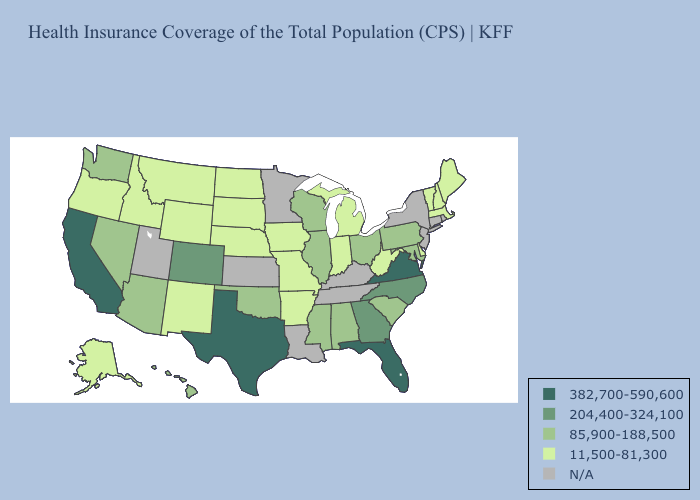What is the lowest value in the USA?
Keep it brief. 11,500-81,300. Name the states that have a value in the range 11,500-81,300?
Short answer required. Alaska, Arkansas, Delaware, Idaho, Indiana, Iowa, Maine, Massachusetts, Michigan, Missouri, Montana, Nebraska, New Hampshire, New Mexico, North Dakota, Oregon, South Dakota, Vermont, West Virginia, Wyoming. Name the states that have a value in the range 204,400-324,100?
Answer briefly. Colorado, Georgia, North Carolina. Name the states that have a value in the range 204,400-324,100?
Quick response, please. Colorado, Georgia, North Carolina. What is the lowest value in the USA?
Concise answer only. 11,500-81,300. What is the lowest value in the Northeast?
Be succinct. 11,500-81,300. Which states have the highest value in the USA?
Write a very short answer. California, Florida, Texas, Virginia. What is the highest value in the USA?
Answer briefly. 382,700-590,600. What is the value of Georgia?
Short answer required. 204,400-324,100. Which states have the lowest value in the USA?
Short answer required. Alaska, Arkansas, Delaware, Idaho, Indiana, Iowa, Maine, Massachusetts, Michigan, Missouri, Montana, Nebraska, New Hampshire, New Mexico, North Dakota, Oregon, South Dakota, Vermont, West Virginia, Wyoming. Among the states that border Wisconsin , does Illinois have the highest value?
Keep it brief. Yes. What is the value of North Carolina?
Answer briefly. 204,400-324,100. 